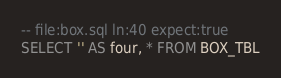Convert code to text. <code><loc_0><loc_0><loc_500><loc_500><_SQL_>-- file:box.sql ln:40 expect:true
SELECT '' AS four, * FROM BOX_TBL
</code> 